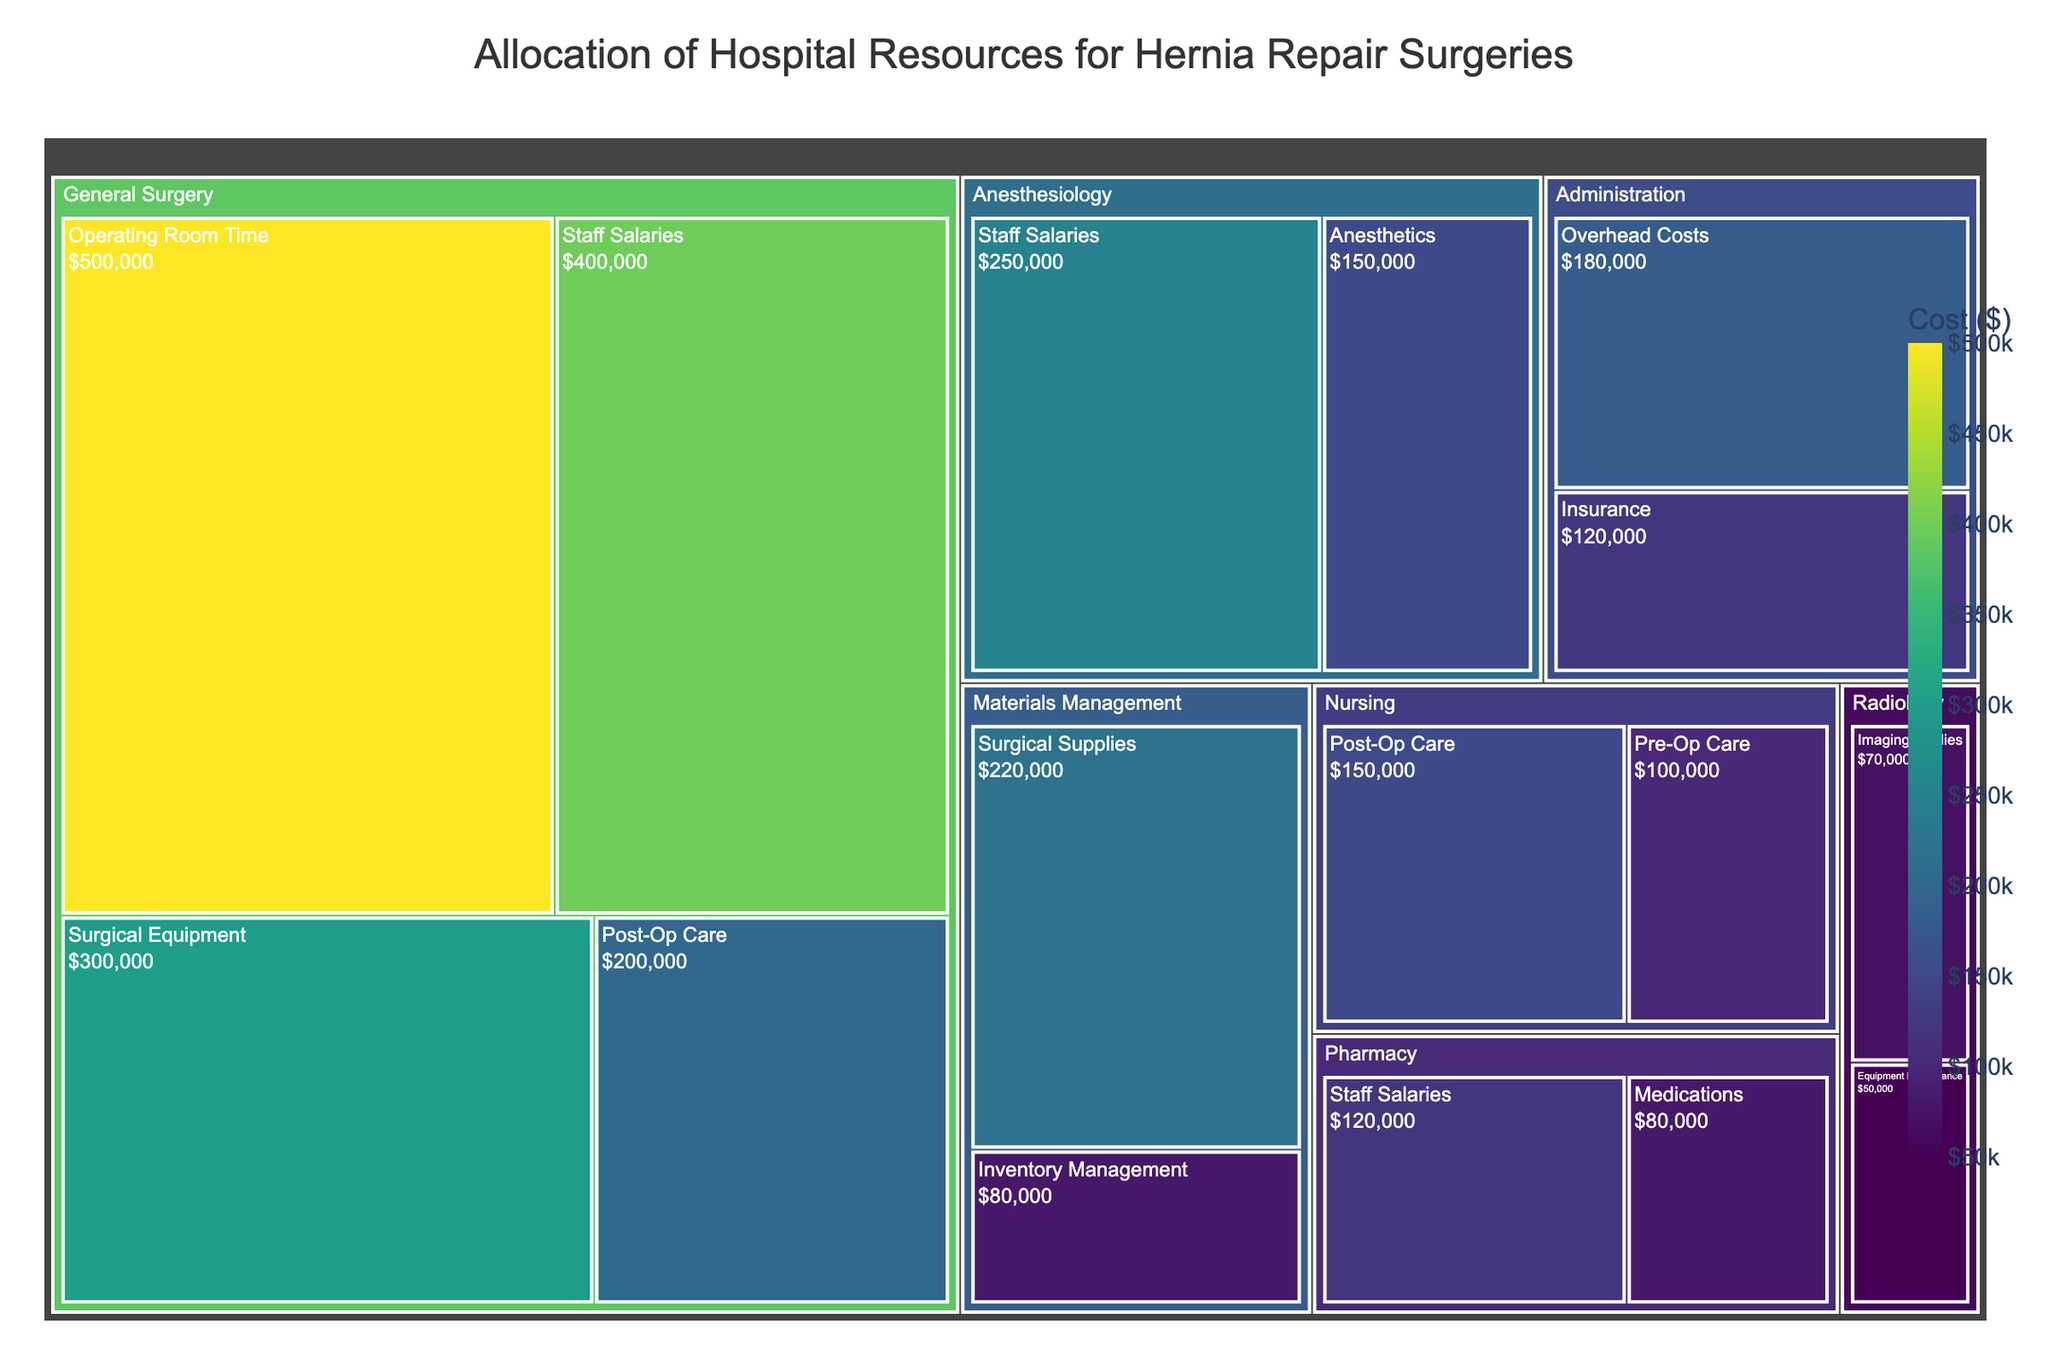what is the highest cost category in the General Surgery department? The treemap shows the categories and their associated costs within each department. In General Surgery, the largest category block has the highest cost. "Operating Room Time" has the highest cost at $500,000.
Answer: Operating Room Time What are the total costs associated with the Nursing department? Sum the costs of all categories within the Nursing department. Pre-Op Care costs $100,000 and Post-Op Care costs $150,000. The total is $100,000 + $150,000 = $250,000.
Answer: $250,000 Which department has the lowest cost category, and what is that category? Examine each department for its smallest cost category. "Radiology" has the "Equipment Maintenance" category with a cost of $50,000, which is the lowest across all departments.
Answer: Radiology, Equipment Maintenance What is the combined cost of Staff Salaries across all departments? Add the costs of all Staff Salaries categories across departments. General Surgery: $400,000, Anesthesiology: $250,000, Pharmacy: $120,000. The total is $400,000 + $250,000 + $120,000 = $770,000.
Answer: $770,000 Which department has the most categories listed, and how many categories does it have? Count the number of categories listed under each department. General Surgery has 4 categories, which is the most among all departments.
Answer: General Surgery, 4 What percentage of total costs is allocated to the Pharmacy department? Sum the costs of all categories in the Pharmacy department and divide by the total costs across all departments. Pharmacy costs: $80,000 (Medications) + $120,000 (Staff Salaries) = $200,000. Total costs: $3,590,000. Percentage is ($200,000 / $3,590,000) * 100 ≈ 5.57%.
Answer: 5.57% Compare the cost of Surgical Equipment in General Surgery to the cost of Anesthetics in Anesthesiology. Which is higher and by how much? General Surgery’s Surgical Equipment costs $300,000, while Anesthesiology’s Anesthetics cost $150,000. Difference is $300,000 - $150,000 = $150,000.
Answer: Surgical Equipment by $150,000 What are the two categories with the highest costs in the entire treemap, and what are those costs? Look for the two largest blocks regardless of department. The highest is "Operating Room Time" in General Surgery at $500,000, followed by "Staff Salaries" in General Surgery at $400,000.
Answer: Operating Room Time: $500,000, Staff Salaries: $400,000 How do the post-op care costs compare between the Nursing and General Surgery departments? Find the costs of Post-Op Care in both departments. Nursing: $150,000, General Surgery: $200,000. General Surgery’s costs are higher by $200,000 - $150,000 = $50,000.
Answer: General Surgery by $50,000 